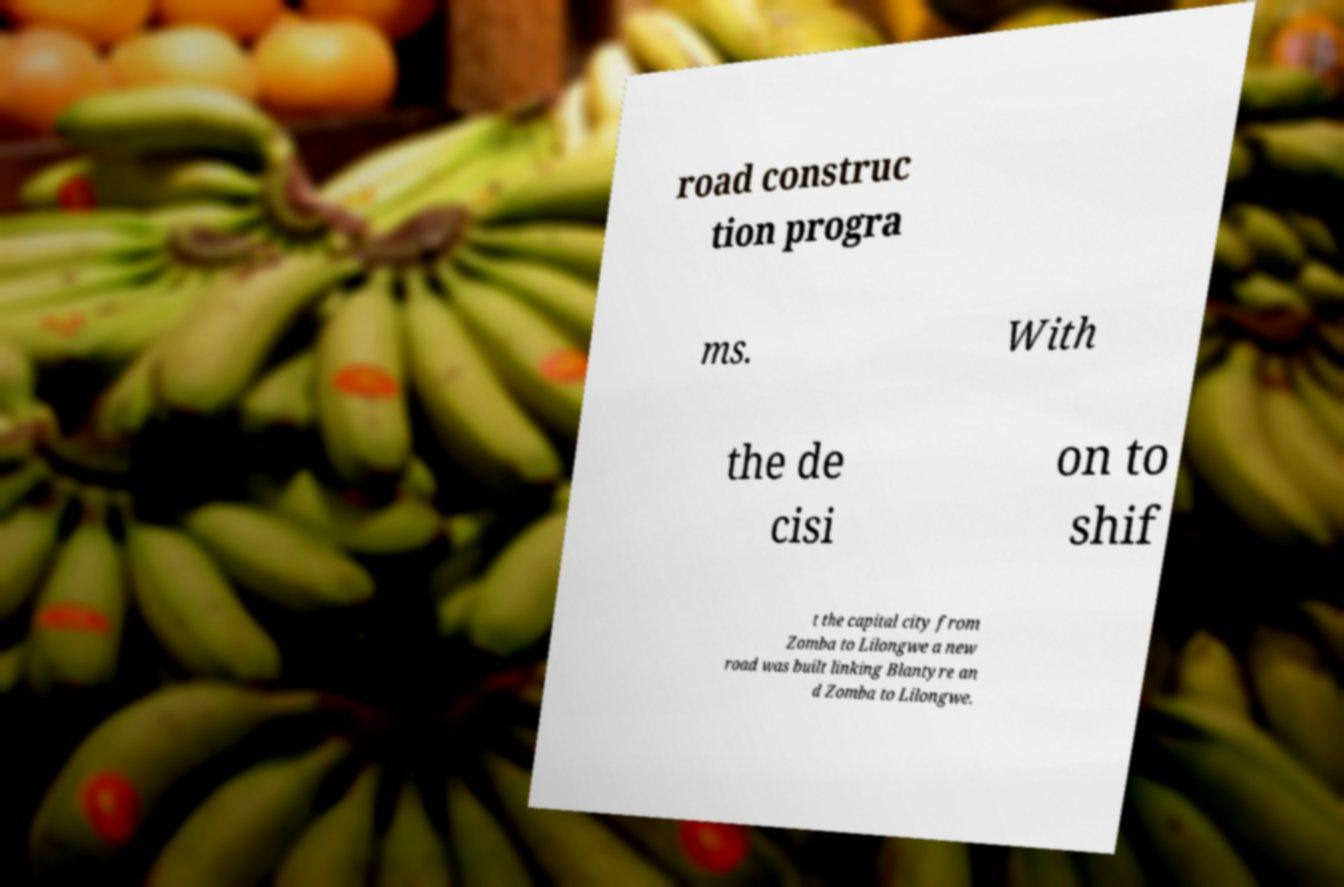There's text embedded in this image that I need extracted. Can you transcribe it verbatim? road construc tion progra ms. With the de cisi on to shif t the capital city from Zomba to Lilongwe a new road was built linking Blantyre an d Zomba to Lilongwe. 